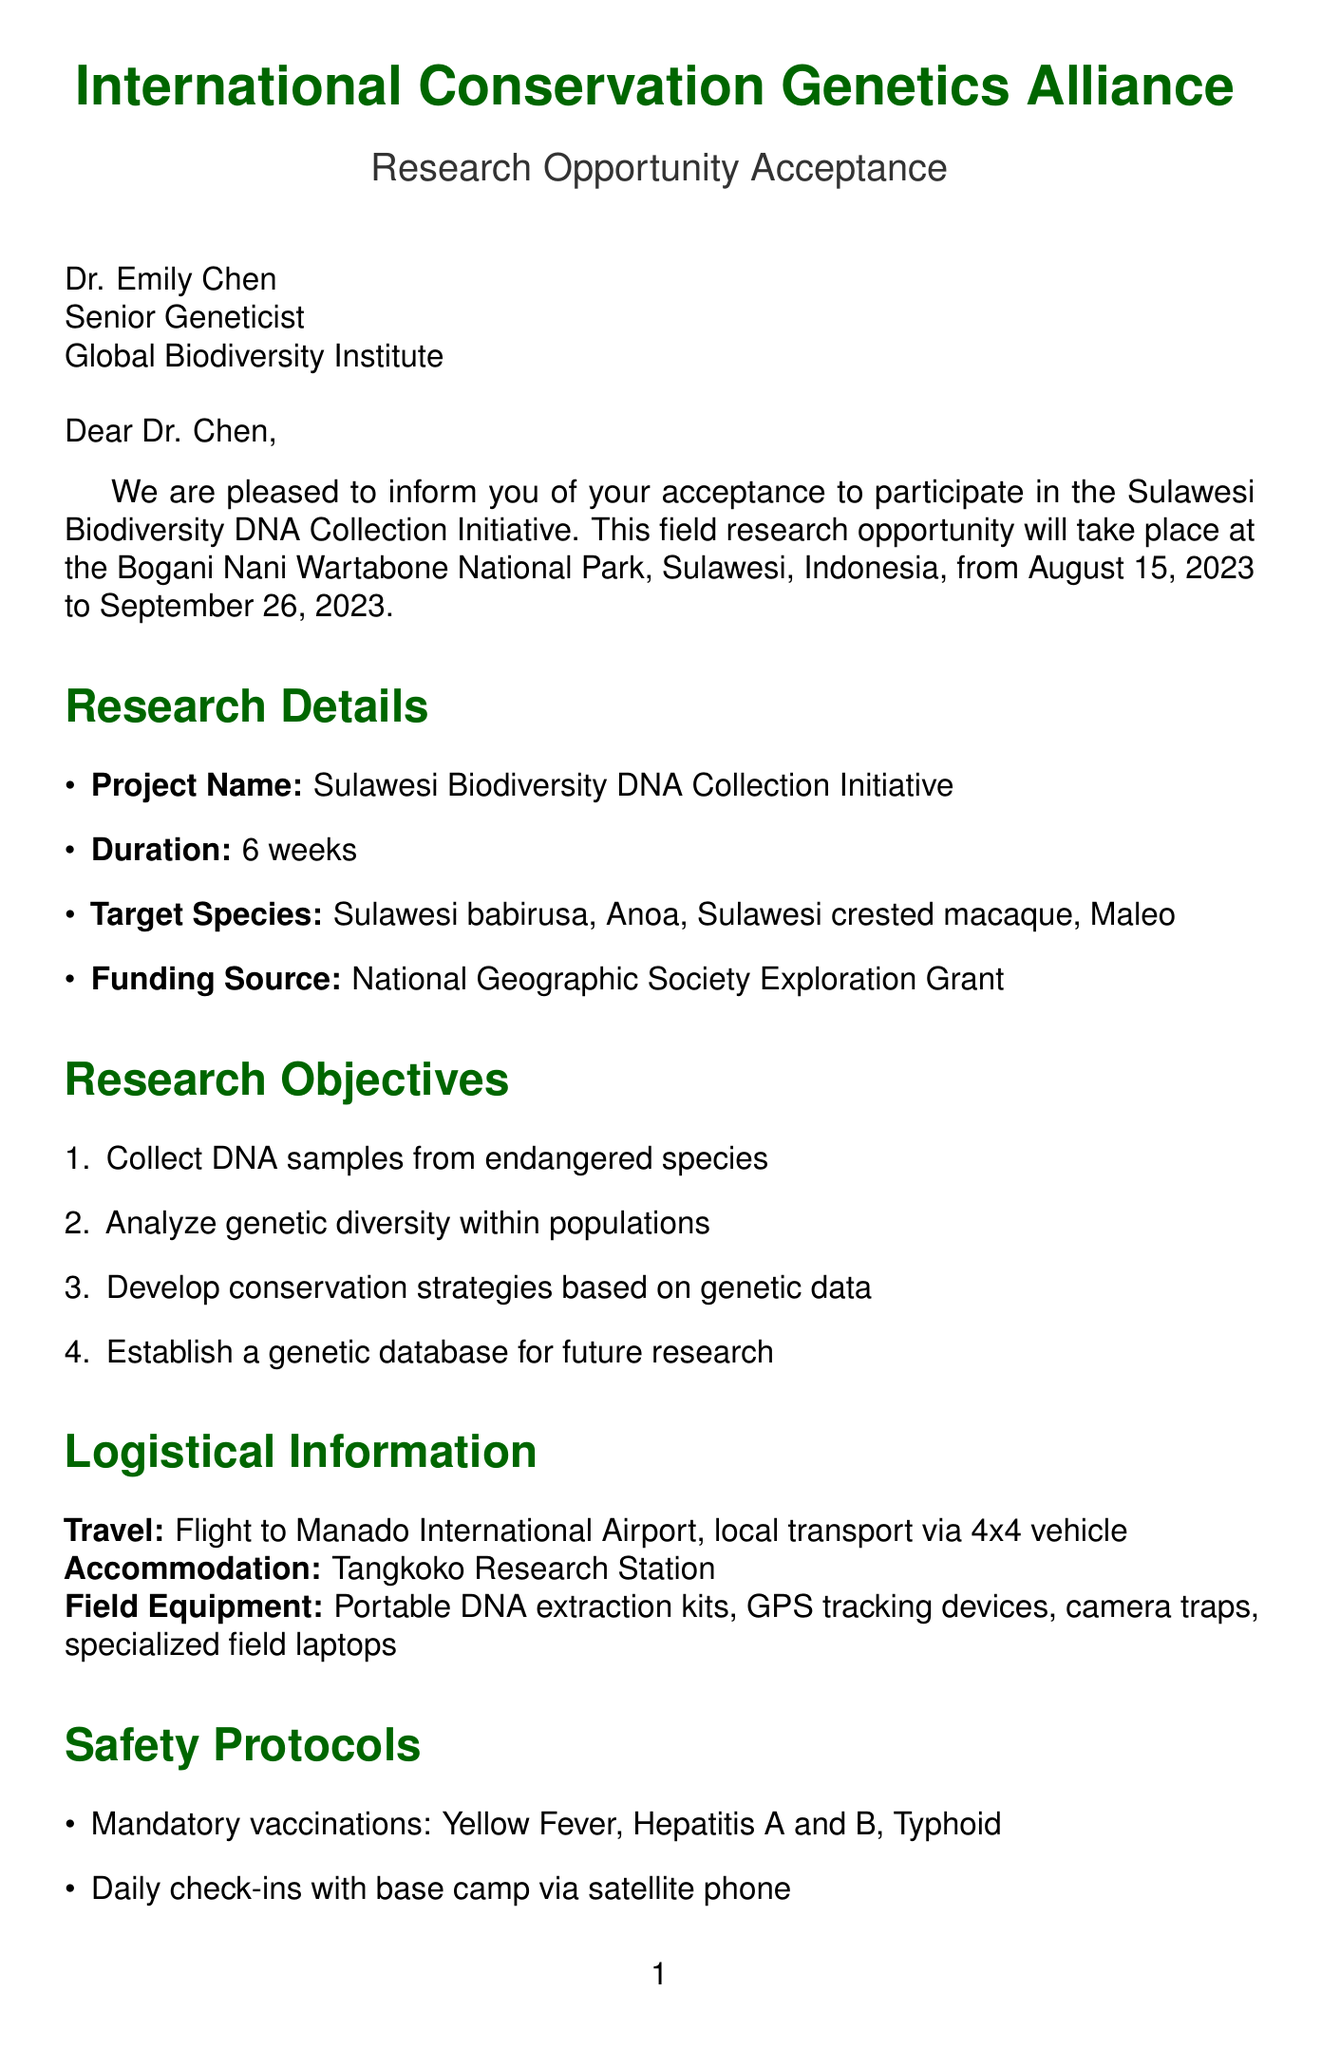What is the project name? The project name is mentioned in the research details section of the document as "Sulawesi Biodiversity DNA Collection Initiative."
Answer: Sulawesi Biodiversity DNA Collection Initiative What is the duration of the field research? The duration is specified in the research details section as 6 weeks.
Answer: 6 weeks When does the research opportunity start? The start date is indicated in the document as August 15, 2023.
Answer: August 15, 2023 What is the target species listed first? The first target species listed in the document is "Sulawesi babirusa."
Answer: Sulawesi babirusa What is the required accommodation for the research team? The accommodation for the research team is stated as "Tangkoko Research Station."
Answer: Tangkoko Research Station How will local transport be provided? Local transport is provided by a 4x4 vehicle according to the logistical information section.
Answer: 4x4 vehicle What is one of the safety protocols mentioned? One of the safety protocols mentioned is "Mandatory vaccinations: Yellow Fever, Hepatitis A and B, Typhoid."
Answer: Mandatory vaccinations: Yellow Fever, Hepatitis A and B, Typhoid What must participants submit by July 1, 2023? Participants must submit "all required documentation" by the specified date.
Answer: all required documentation 